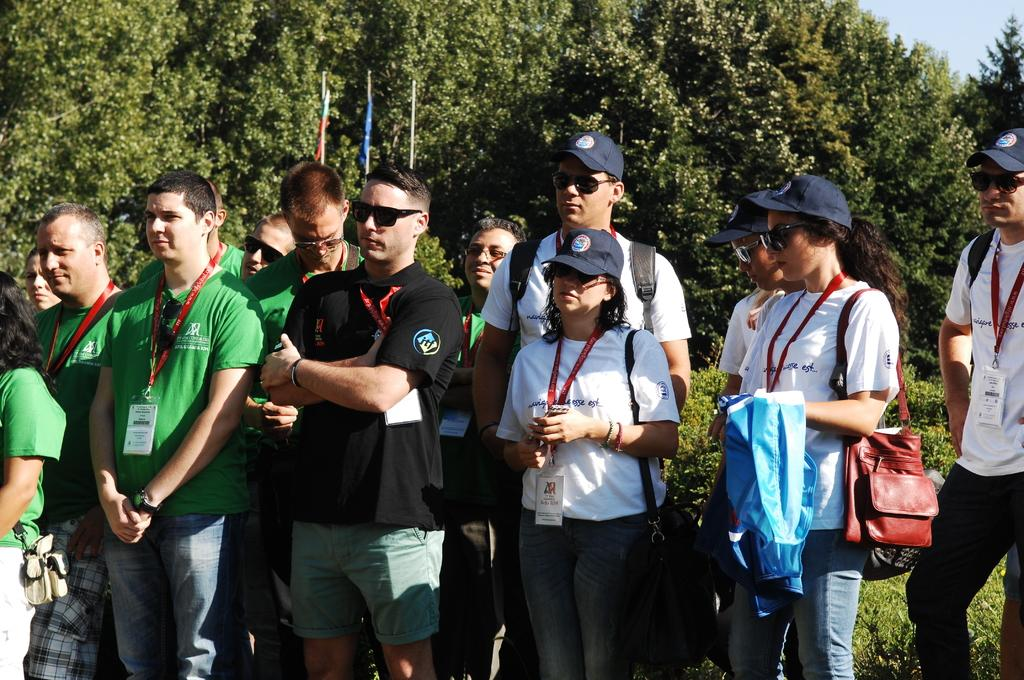What is the main subject of the image? The main subject of the image is a group of people. Where are the people located in the image? The people are standing in the center of the image. What can be seen in the background of the image? There are trees in the background of the image. What type of meat is being served at the discussion in the image? There is no discussion or meat present in the image; it features a group of people standing in the center with trees in the background. 